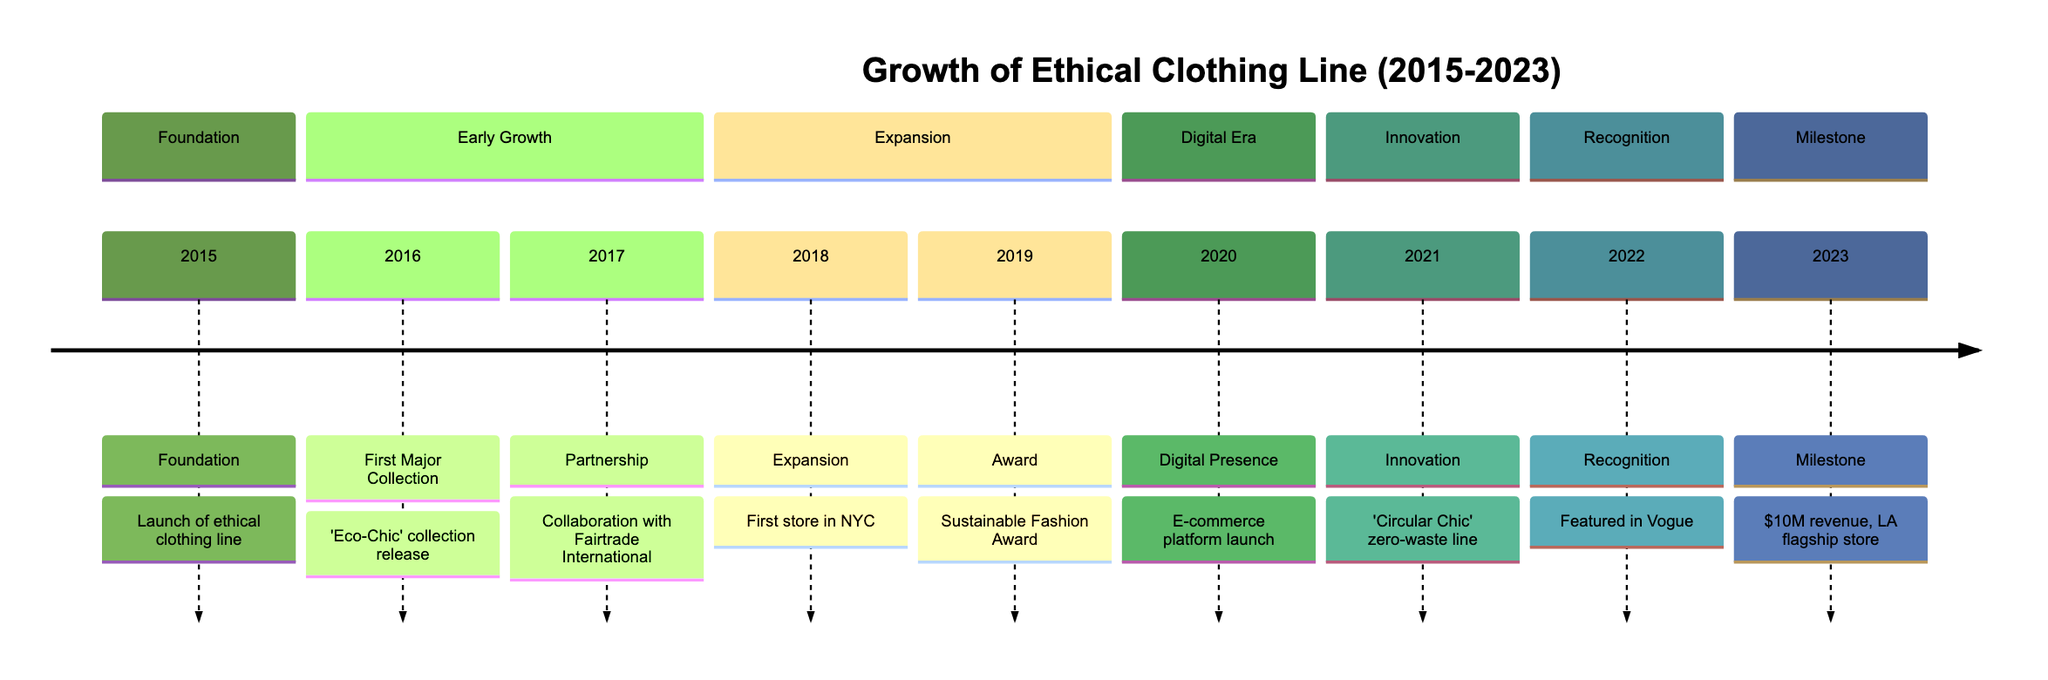What year was the designer's ethical clothing line founded? The timeline shows the event "Foundation" occurring in 2015, which marks the launch of the designer's ethical clothing line. Hence, the founding year is directly indicated as 2015.
Answer: 2015 What was the first major collection released by the designer? According to the timeline, the event "First Major Collection" in 2016 mentions the release of the 'Eco-Chic' collection. Therefore, this collection is the first major one.
Answer: Eco-Chic Which year did the designer open their first physical store? The timeline indicates that the "Expansion" event, marked in 2018, involved opening the first brick-and-mortar store in New York City. Thus, 2018 is the year of this expansion.
Answer: 2018 How much annual revenue did the designer surpass in 2023? The timeline states that in 2023, the milestone was surpassing $10 million in annual revenue. This figure is explicitly mentioned as the revenue achieved by that year.
Answer: $10 million What significant recognition was achieved in 2022? The timeline shows an event called "Recognition" in 2022, highlighting that the designer was featured in Vogue's 'Top 10 Ethical Designers to Watch.' This event signifies the recognition gained that year.
Answer: Featured in Vogue In which year did the designer introduce the "Circular Chic" zero-waste line? The timeline presents the event "Innovation" for the year 2021, which marks the introduction of the zero-waste line named 'Circular Chic.' Hence, this product line was launched in 2021.
Answer: 2021 How many major events are recorded in the timeline overall? By counting the listed events in the timeline, which includes Foundation, First Major Collection, Partnership, Expansion, Award, Digital Presence, Innovation, Recognition, and Milestone, we determine that there are a total of nine major events documented from 2015 to 2023.
Answer: 9 What was the year of the designer's first award? The "Award" event on the timeline indicates that the designer won the Sustainable Fashion Award in 2019, thereby explicitly providing the year when this recognition was received.
Answer: 2019 What partnership was formed in 2017? The timeline notes the "Partnership" event in 2017, which involved collaboration with Fairtrade International to ensure ethically sourced materials. This directly points to the type of partnership established in that year.
Answer: Fairtrade International 